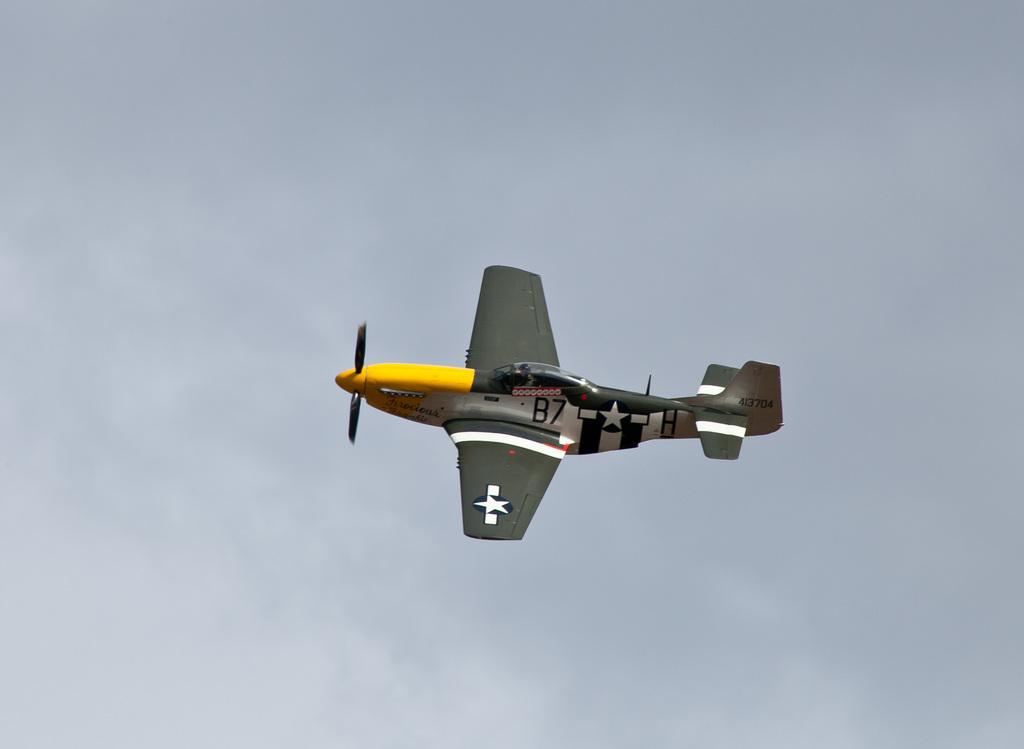What is the plane number below the cockpit?
Give a very brief answer. B7. 